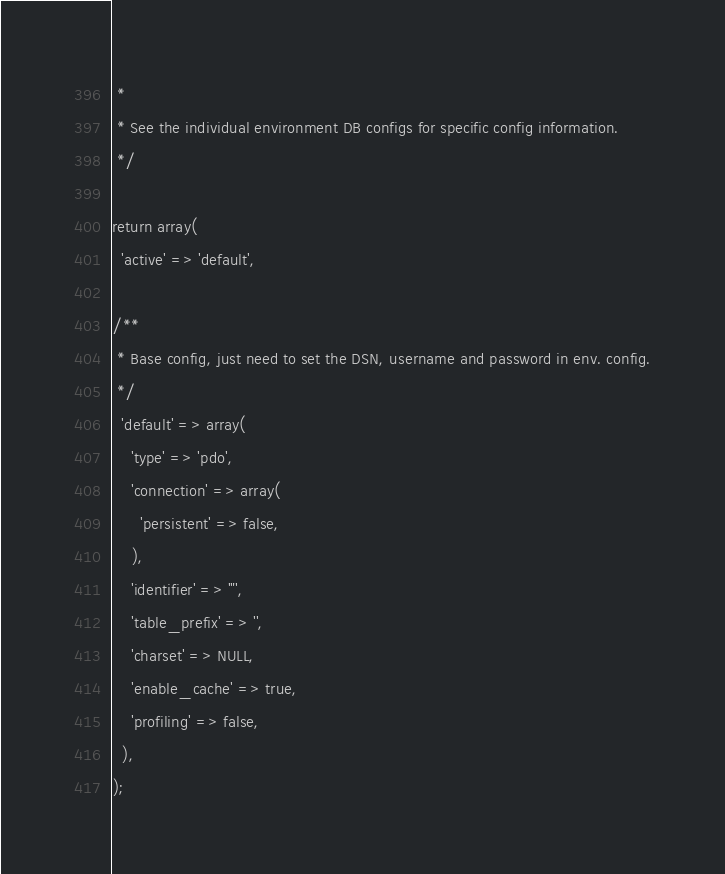<code> <loc_0><loc_0><loc_500><loc_500><_PHP_> *
 * See the individual environment DB configs for specific config information.
 */

return array(
  'active' => 'default',
 
/**
 * Base config, just need to set the DSN, username and password in env. config.
 */
  'default' => array(
    'type' => 'pdo',
    'connection' => array(
      'persistent' => false,
    ),
    'identifier' => '"',
    'table_prefix' => '',
    'charset' => NULL,
    'enable_cache' => true,
    'profiling' => false,
  ),
);</code> 